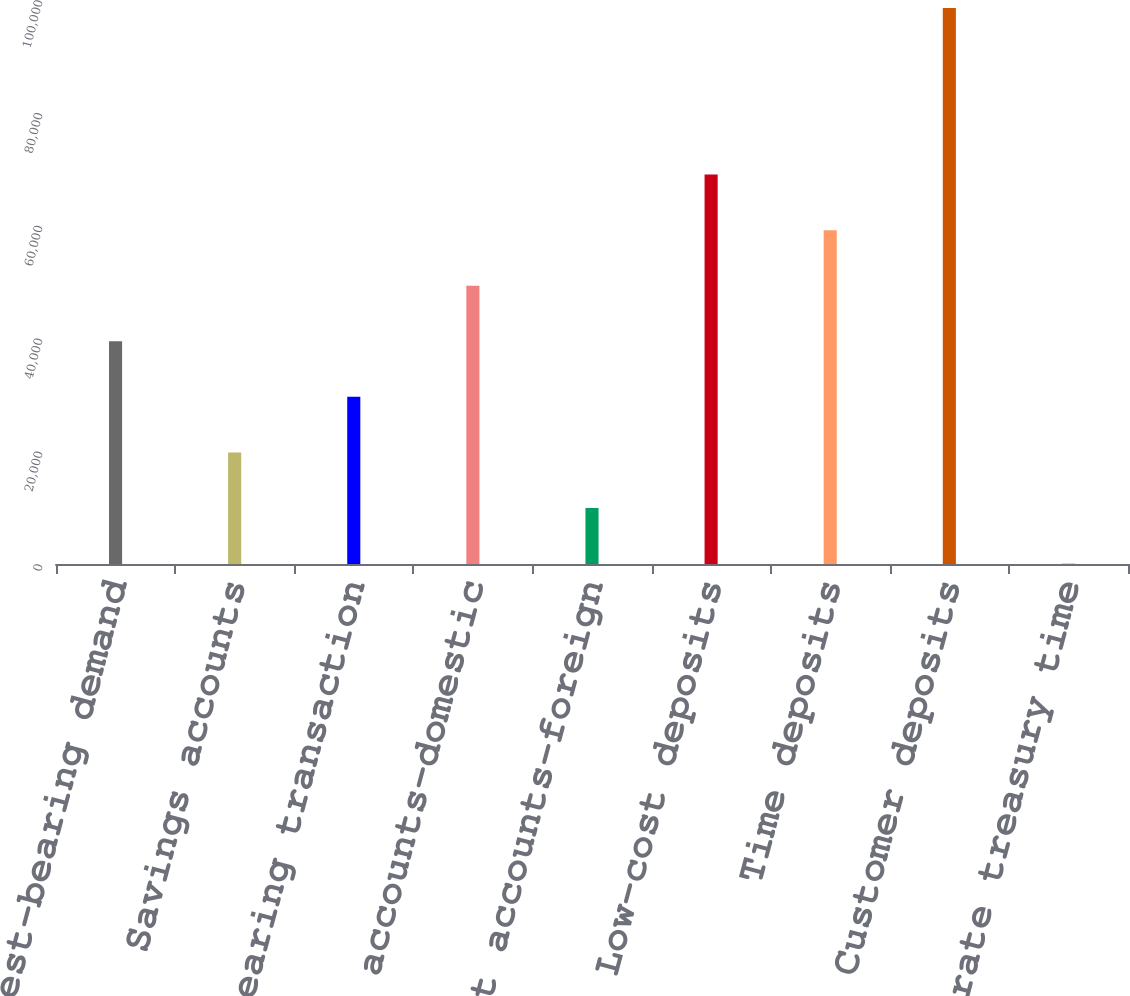<chart> <loc_0><loc_0><loc_500><loc_500><bar_chart><fcel>Non-interest-bearing demand<fcel>Savings accounts<fcel>Interest-bearing transaction<fcel>Money market accounts-domestic<fcel>Money market accounts-foreign<fcel>Low-cost deposits<fcel>Time deposits<fcel>Customer deposits<fcel>Corporate treasury time<nl><fcel>39489.4<fcel>19788.2<fcel>29638.8<fcel>49340<fcel>9937.6<fcel>69041.2<fcel>59190.6<fcel>98593<fcel>87<nl></chart> 